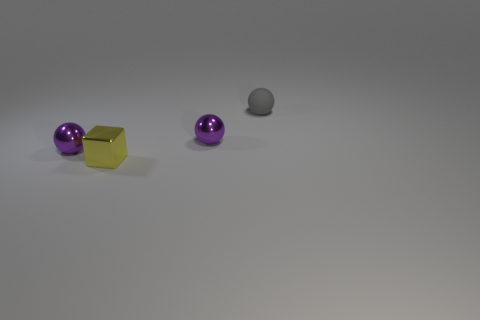Subtract all purple balls. How many balls are left? 1 Subtract all gray cylinders. How many purple balls are left? 2 Add 1 tiny purple things. How many objects exist? 5 Subtract all brown spheres. Subtract all gray cylinders. How many spheres are left? 3 Add 4 matte things. How many matte things are left? 5 Add 4 spheres. How many spheres exist? 7 Subtract 0 blue balls. How many objects are left? 4 Subtract all cubes. How many objects are left? 3 Subtract all gray rubber balls. Subtract all small matte things. How many objects are left? 2 